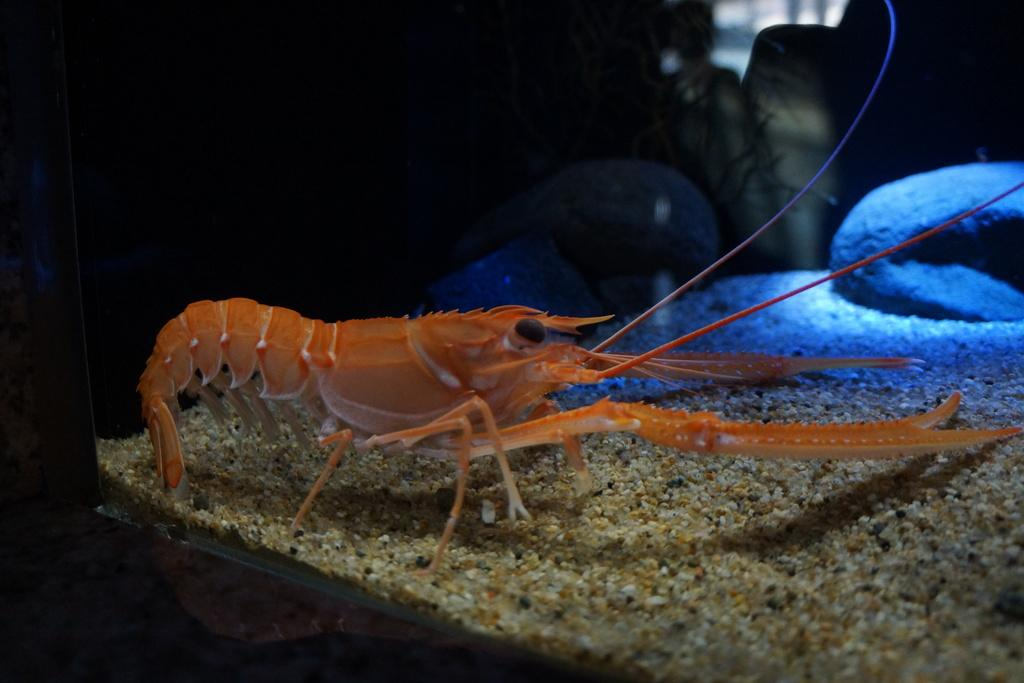What type of sea creature is in the image? There is an American lobster in the image. Where is the American lobster located? The American lobster is in an aquarium. What can be seen in the background of the image? There are stones visible in the background of the image. What type of chain is hanging from the lamp in the image? There is no chain or lamp present in the image; it only features an American lobster in an aquarium with stones in the background. 